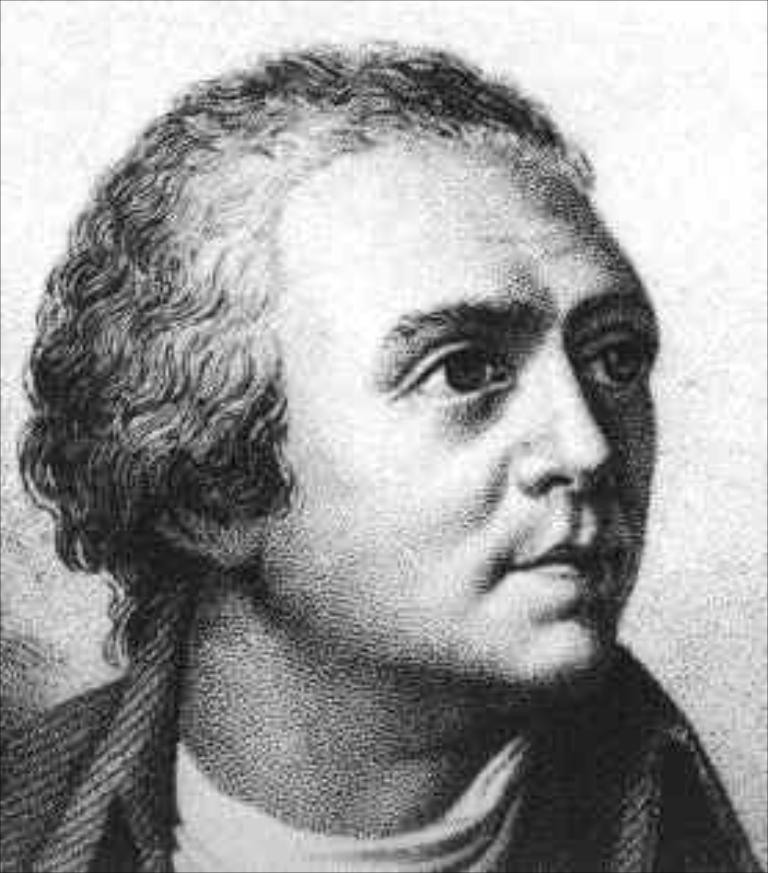What is the main subject in the photo? There is a person in the photo. What type of fuel is the person using to power their vehicle in the image? There is no vehicle or fuel present in the image; it features a person. How many bricks can be seen stacked on the person's foot in the image? There are no bricks or feet visible in the image; it features a person. 